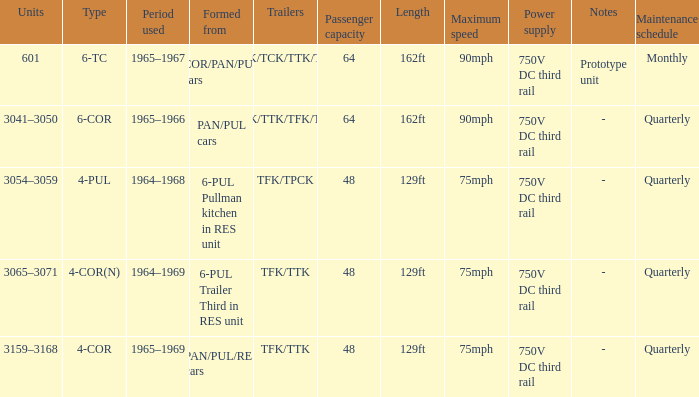Name the typed for formed from 6-pul trailer third in res unit 4-COR(N). 